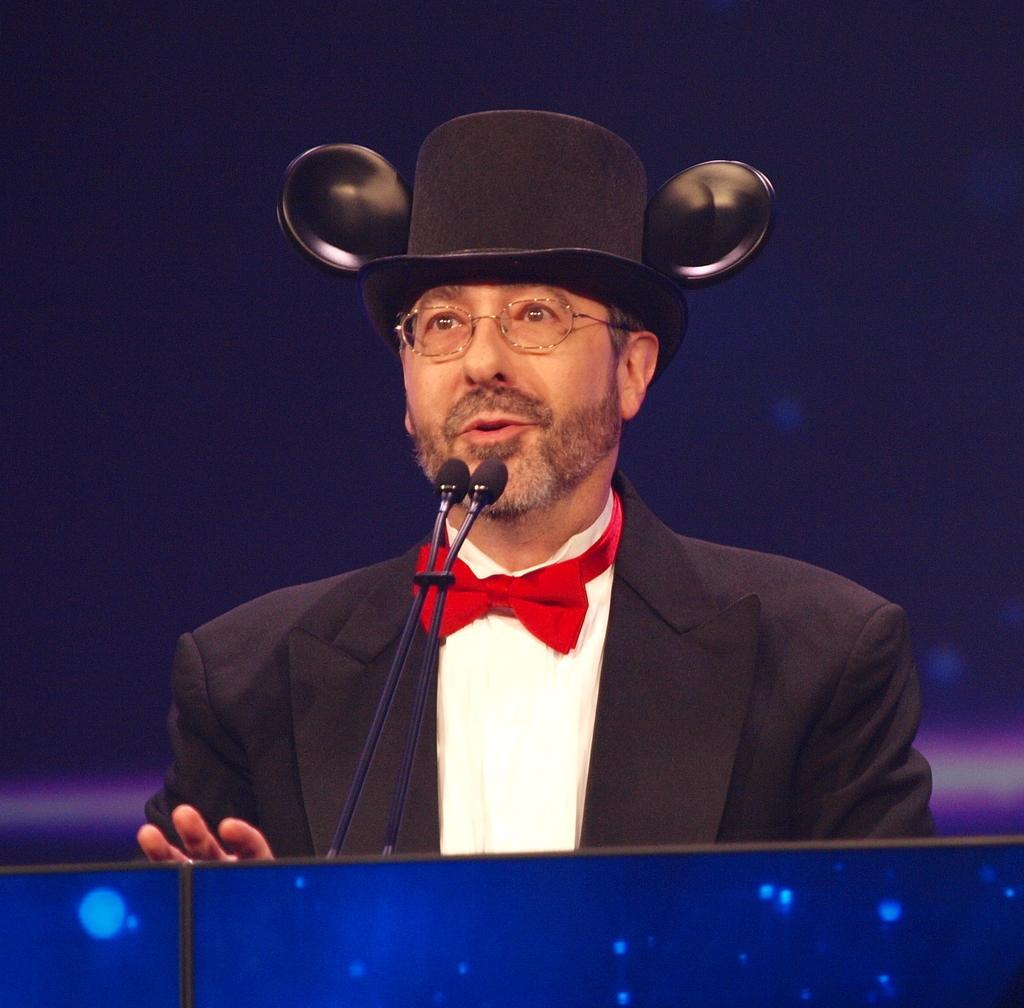How would you summarize this image in a sentence or two? In this image there is a man standing near a podium and there are mike's, in the background there is a wall. 